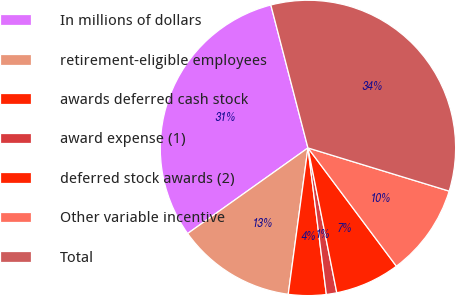Convert chart to OTSL. <chart><loc_0><loc_0><loc_500><loc_500><pie_chart><fcel>In millions of dollars<fcel>retirement-eligible employees<fcel>awards deferred cash stock<fcel>award expense (1)<fcel>deferred stock awards (2)<fcel>Other variable incentive<fcel>Total<nl><fcel>30.8%<fcel>13.03%<fcel>4.12%<fcel>1.14%<fcel>7.09%<fcel>10.06%<fcel>33.77%<nl></chart> 